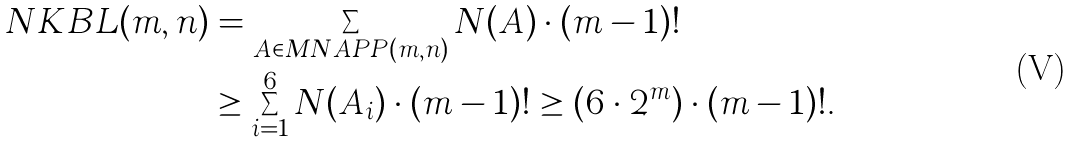Convert formula to latex. <formula><loc_0><loc_0><loc_500><loc_500>N K B L ( m , n ) & = \sum _ { A \in M N A P P ( m , n ) } N ( A ) \cdot ( m - 1 ) ! \\ & \geq \sum _ { i = 1 } ^ { 6 } N ( A _ { i } ) \cdot ( m - 1 ) ! \geq ( 6 \cdot 2 ^ { m } ) \cdot ( m - 1 ) ! .</formula> 